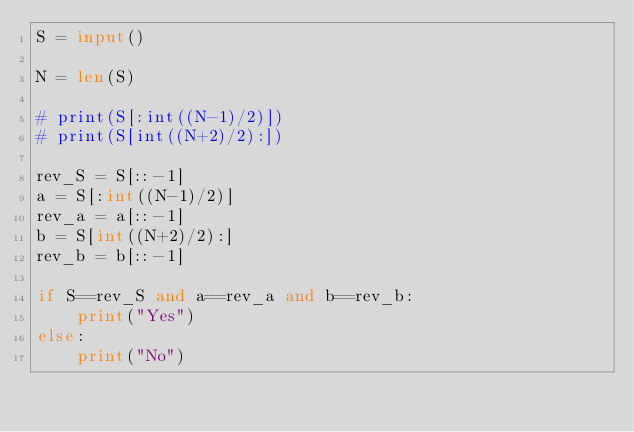Convert code to text. <code><loc_0><loc_0><loc_500><loc_500><_Python_>S = input()

N = len(S)

# print(S[:int((N-1)/2)])
# print(S[int((N+2)/2):])

rev_S = S[::-1]
a = S[:int((N-1)/2)]
rev_a = a[::-1]
b = S[int((N+2)/2):]
rev_b = b[::-1]

if S==rev_S and a==rev_a and b==rev_b:
    print("Yes")
else:
    print("No")
</code> 